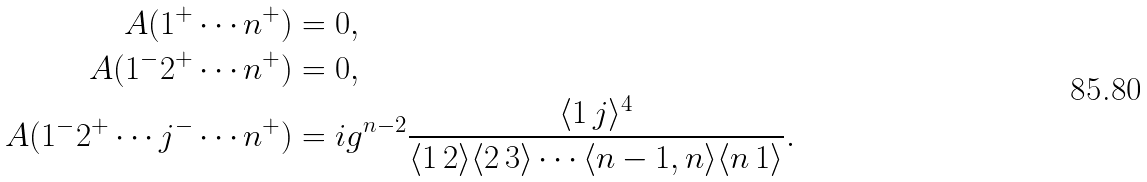Convert formula to latex. <formula><loc_0><loc_0><loc_500><loc_500>A ( 1 ^ { + } \cdots n ^ { + } ) & = 0 , \\ A ( 1 ^ { - } 2 ^ { + } \cdots n ^ { + } ) & = 0 , \\ A ( 1 ^ { - } 2 ^ { + } \cdots j ^ { - } \cdots n ^ { + } ) & = i g ^ { n - 2 } \frac { \langle 1 \, j \rangle ^ { 4 } } { \langle 1 \, 2 \rangle \langle 2 \, 3 \rangle \cdots \langle n - 1 , n \rangle \langle n \, 1 \rangle } .</formula> 